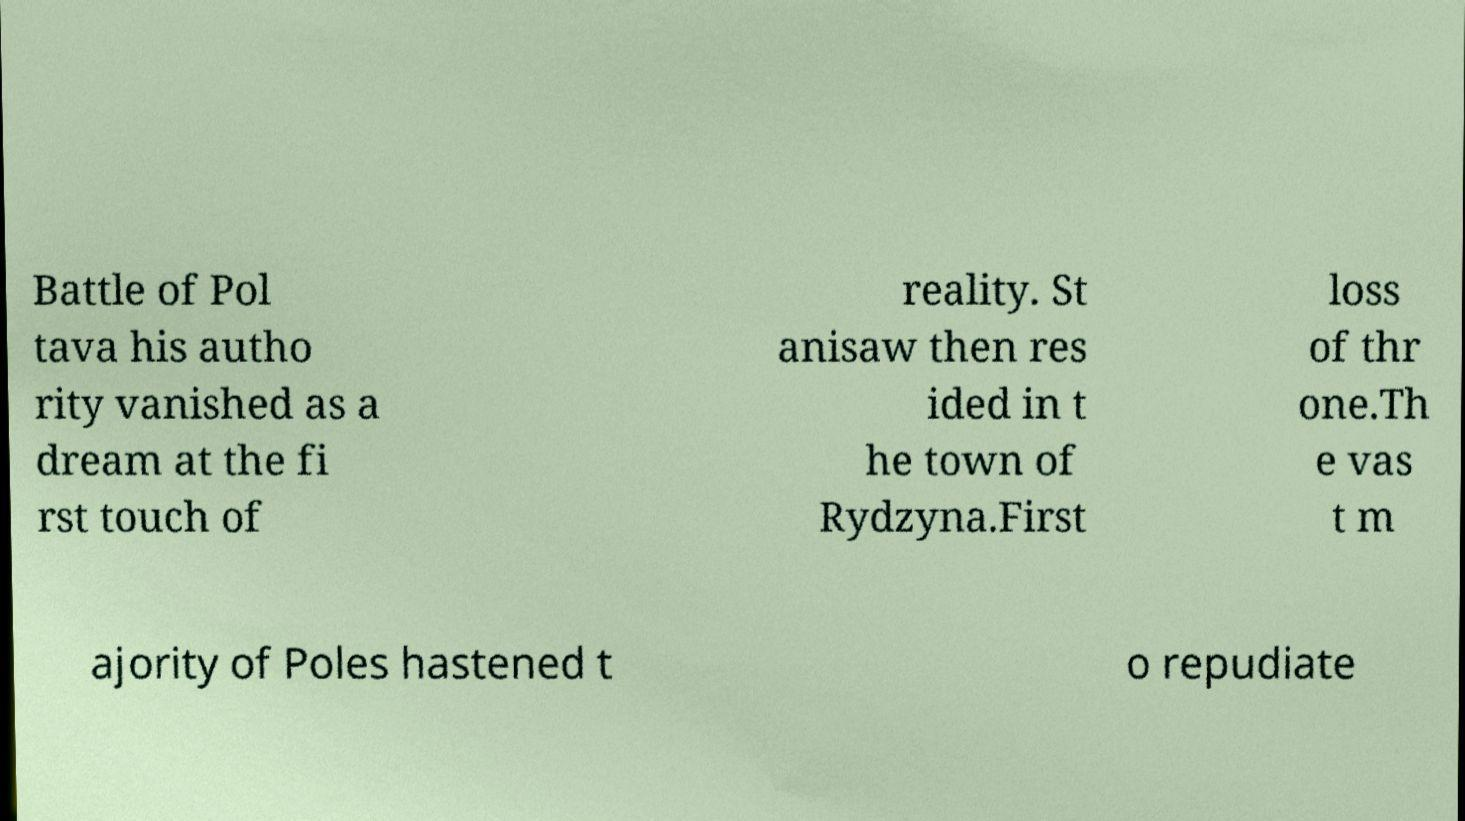What messages or text are displayed in this image? I need them in a readable, typed format. Battle of Pol tava his autho rity vanished as a dream at the fi rst touch of reality. St anisaw then res ided in t he town of Rydzyna.First loss of thr one.Th e vas t m ajority of Poles hastened t o repudiate 